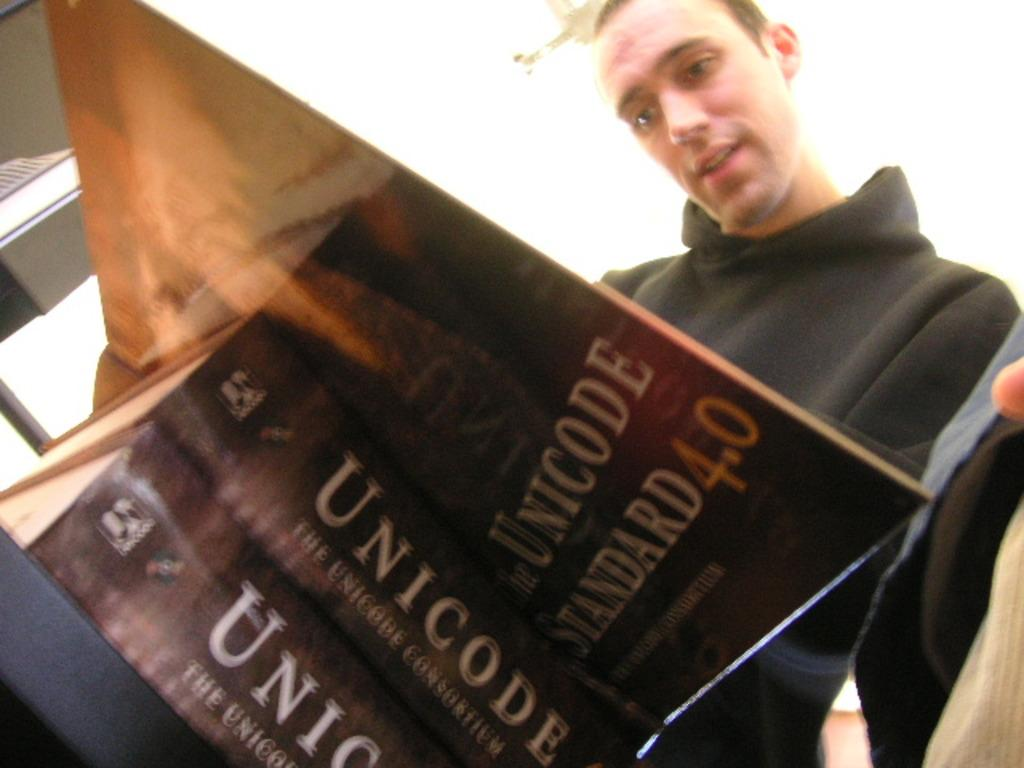<image>
Share a concise interpretation of the image provided. A man looking at an open book with a book under it that says Unicode on it. 